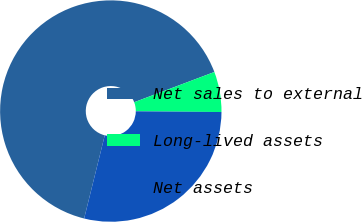<chart> <loc_0><loc_0><loc_500><loc_500><pie_chart><fcel>Net sales to external<fcel>Long-lived assets<fcel>Net assets<nl><fcel>65.39%<fcel>5.88%<fcel>28.73%<nl></chart> 